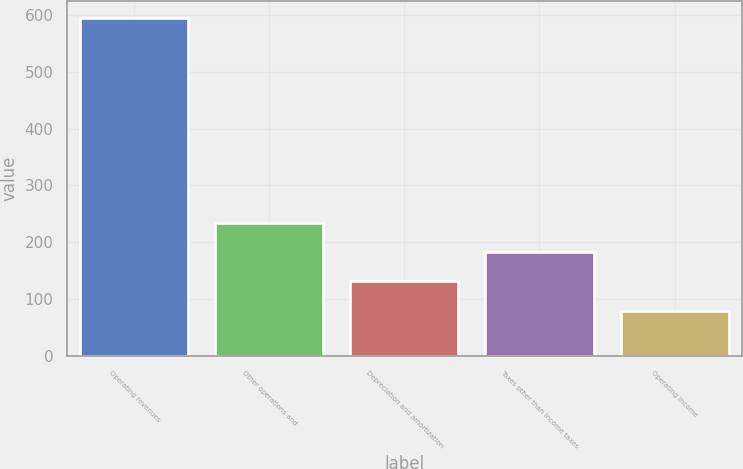<chart> <loc_0><loc_0><loc_500><loc_500><bar_chart><fcel>Operating revenues<fcel>Other operations and<fcel>Depreciation and amortization<fcel>Taxes other than income taxes<fcel>Operating income<nl><fcel>595<fcel>234.5<fcel>131.5<fcel>183<fcel>80<nl></chart> 